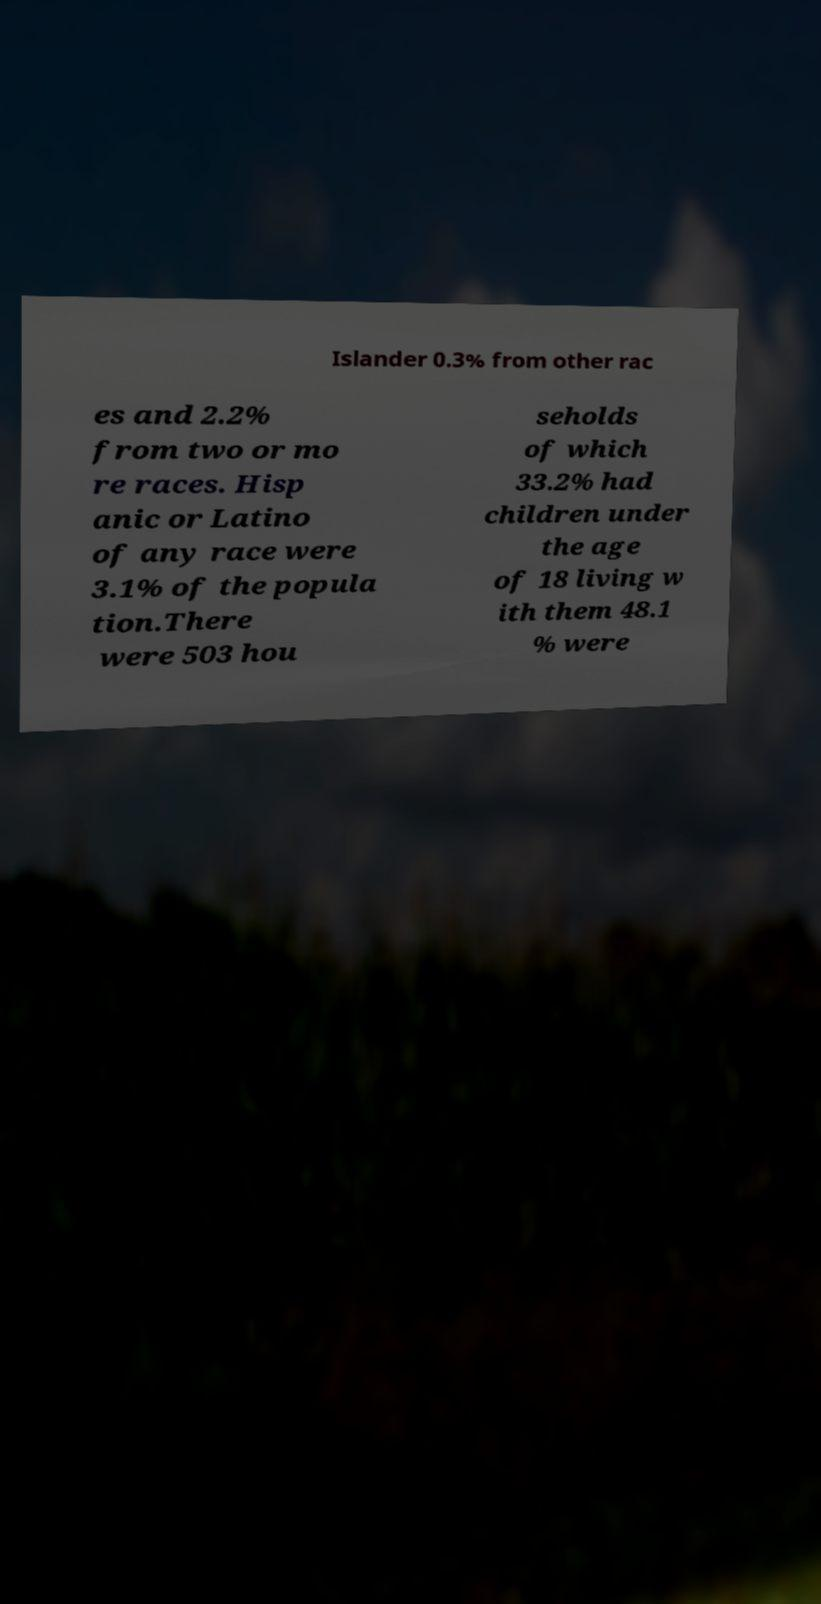For documentation purposes, I need the text within this image transcribed. Could you provide that? Islander 0.3% from other rac es and 2.2% from two or mo re races. Hisp anic or Latino of any race were 3.1% of the popula tion.There were 503 hou seholds of which 33.2% had children under the age of 18 living w ith them 48.1 % were 